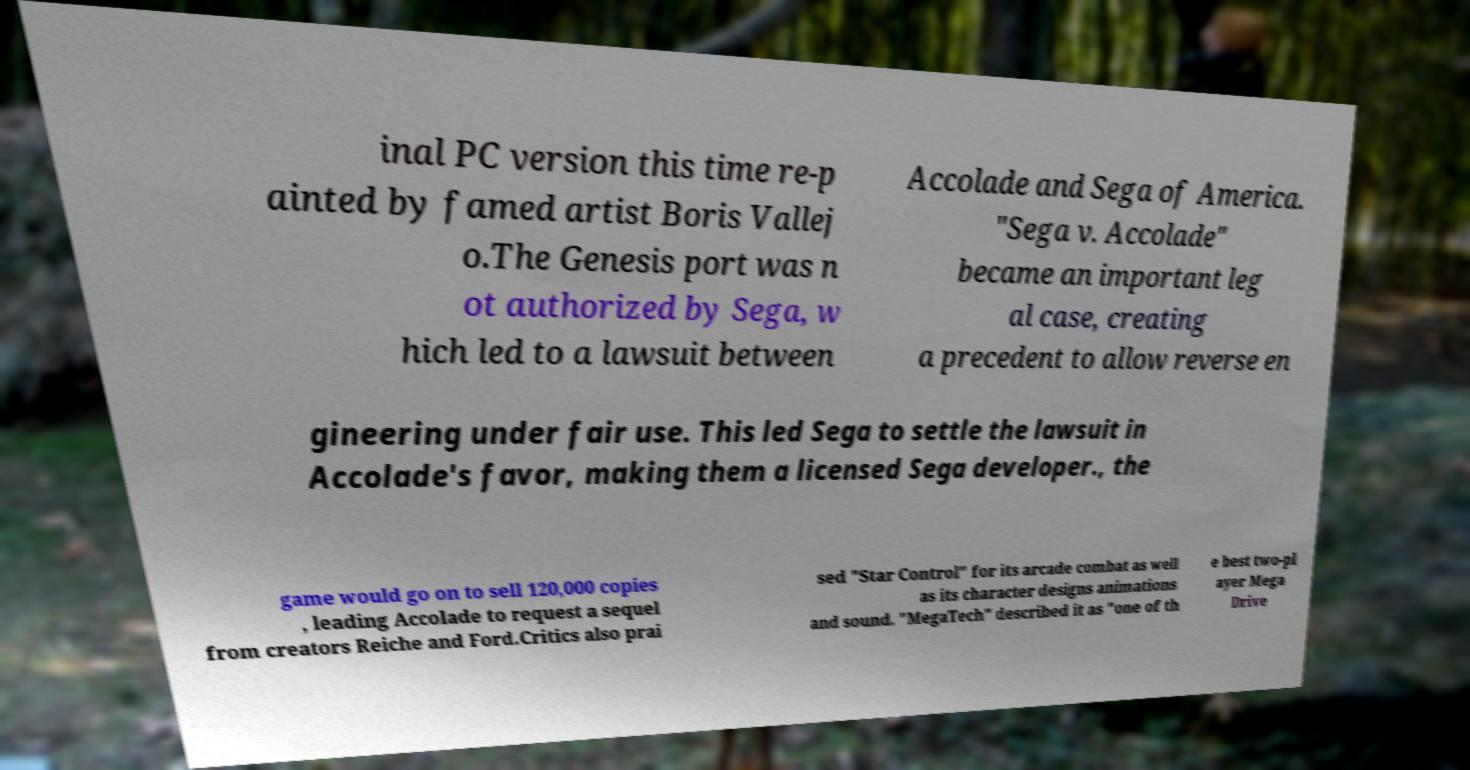Could you assist in decoding the text presented in this image and type it out clearly? inal PC version this time re-p ainted by famed artist Boris Vallej o.The Genesis port was n ot authorized by Sega, w hich led to a lawsuit between Accolade and Sega of America. "Sega v. Accolade" became an important leg al case, creating a precedent to allow reverse en gineering under fair use. This led Sega to settle the lawsuit in Accolade's favor, making them a licensed Sega developer., the game would go on to sell 120,000 copies , leading Accolade to request a sequel from creators Reiche and Ford.Critics also prai sed "Star Control" for its arcade combat as well as its character designs animations and sound. "MegaTech" described it as "one of th e best two-pl ayer Mega Drive 